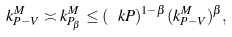<formula> <loc_0><loc_0><loc_500><loc_500>k ^ { M } _ { P - V } \asymp k ^ { M } _ { P _ { \beta } } \leq ( \ k P ) ^ { 1 - \beta } ( k ^ { M } _ { P - V } ) ^ { \beta } ,</formula> 